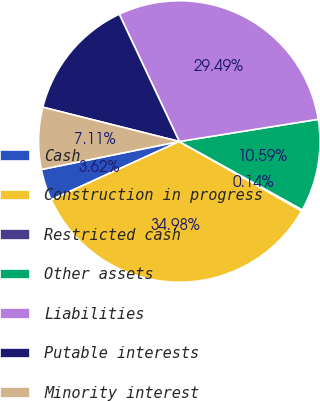<chart> <loc_0><loc_0><loc_500><loc_500><pie_chart><fcel>Cash<fcel>Construction in progress<fcel>Restricted cash<fcel>Other assets<fcel>Liabilities<fcel>Putable interests<fcel>Minority interest<nl><fcel>3.62%<fcel>34.98%<fcel>0.14%<fcel>10.59%<fcel>29.49%<fcel>14.07%<fcel>7.11%<nl></chart> 